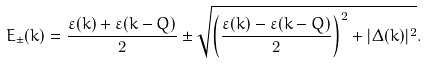<formula> <loc_0><loc_0><loc_500><loc_500>E _ { \pm } ( { k } ) = \frac { \varepsilon ( { k } ) + \varepsilon ( { k - Q } ) } { 2 } \pm \sqrt { \left ( \frac { \varepsilon ( { k } ) - \varepsilon ( { k - Q } ) } { 2 } \right ) ^ { 2 } + | \Delta ( { k } ) | ^ { 2 } } .</formula> 